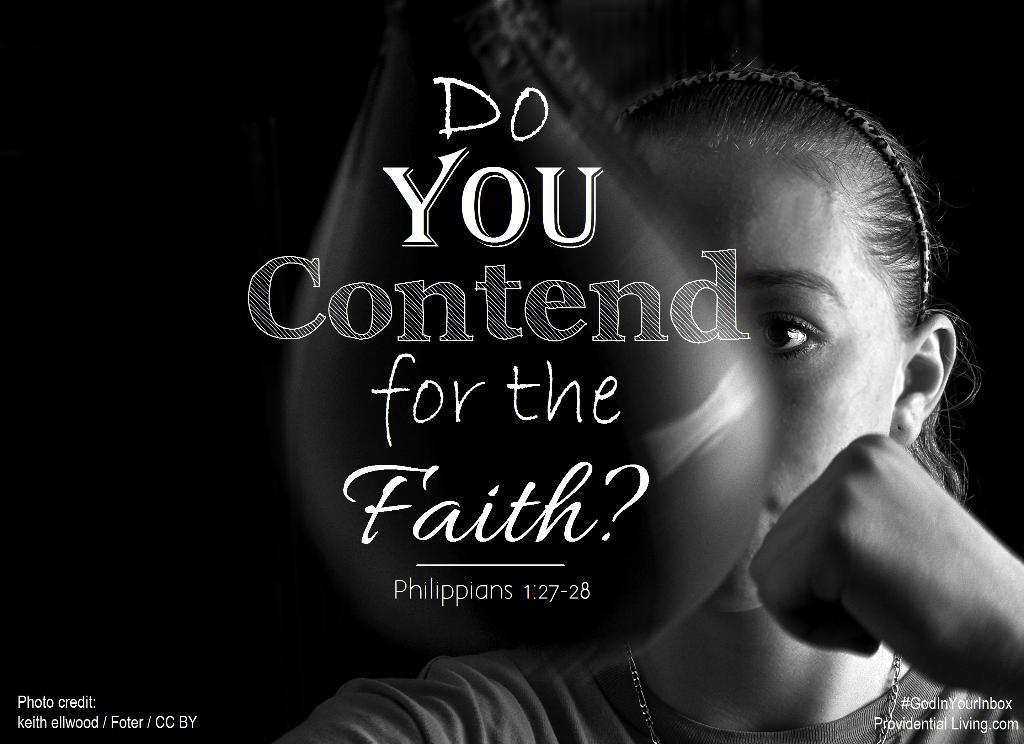What is the color scheme of the image? The image is black and white. Has the image been altered in any way? Yes, the image is edited. Where is the woman located in the image? The woman is on the right side of the image. What can be seen in the middle of the image? There is something written in the middle of the image. What arithmetic problem is the woman solving in the image? There is no arithmetic problem visible in the image, as it is a black and white, edited image with a woman on the right side and something written in the middle. Can you tell me who the father of the woman is in the image? There is no information about the woman's father in the image, as it only shows a black and white, edited image with a woman on the right side and something written in the middle. 